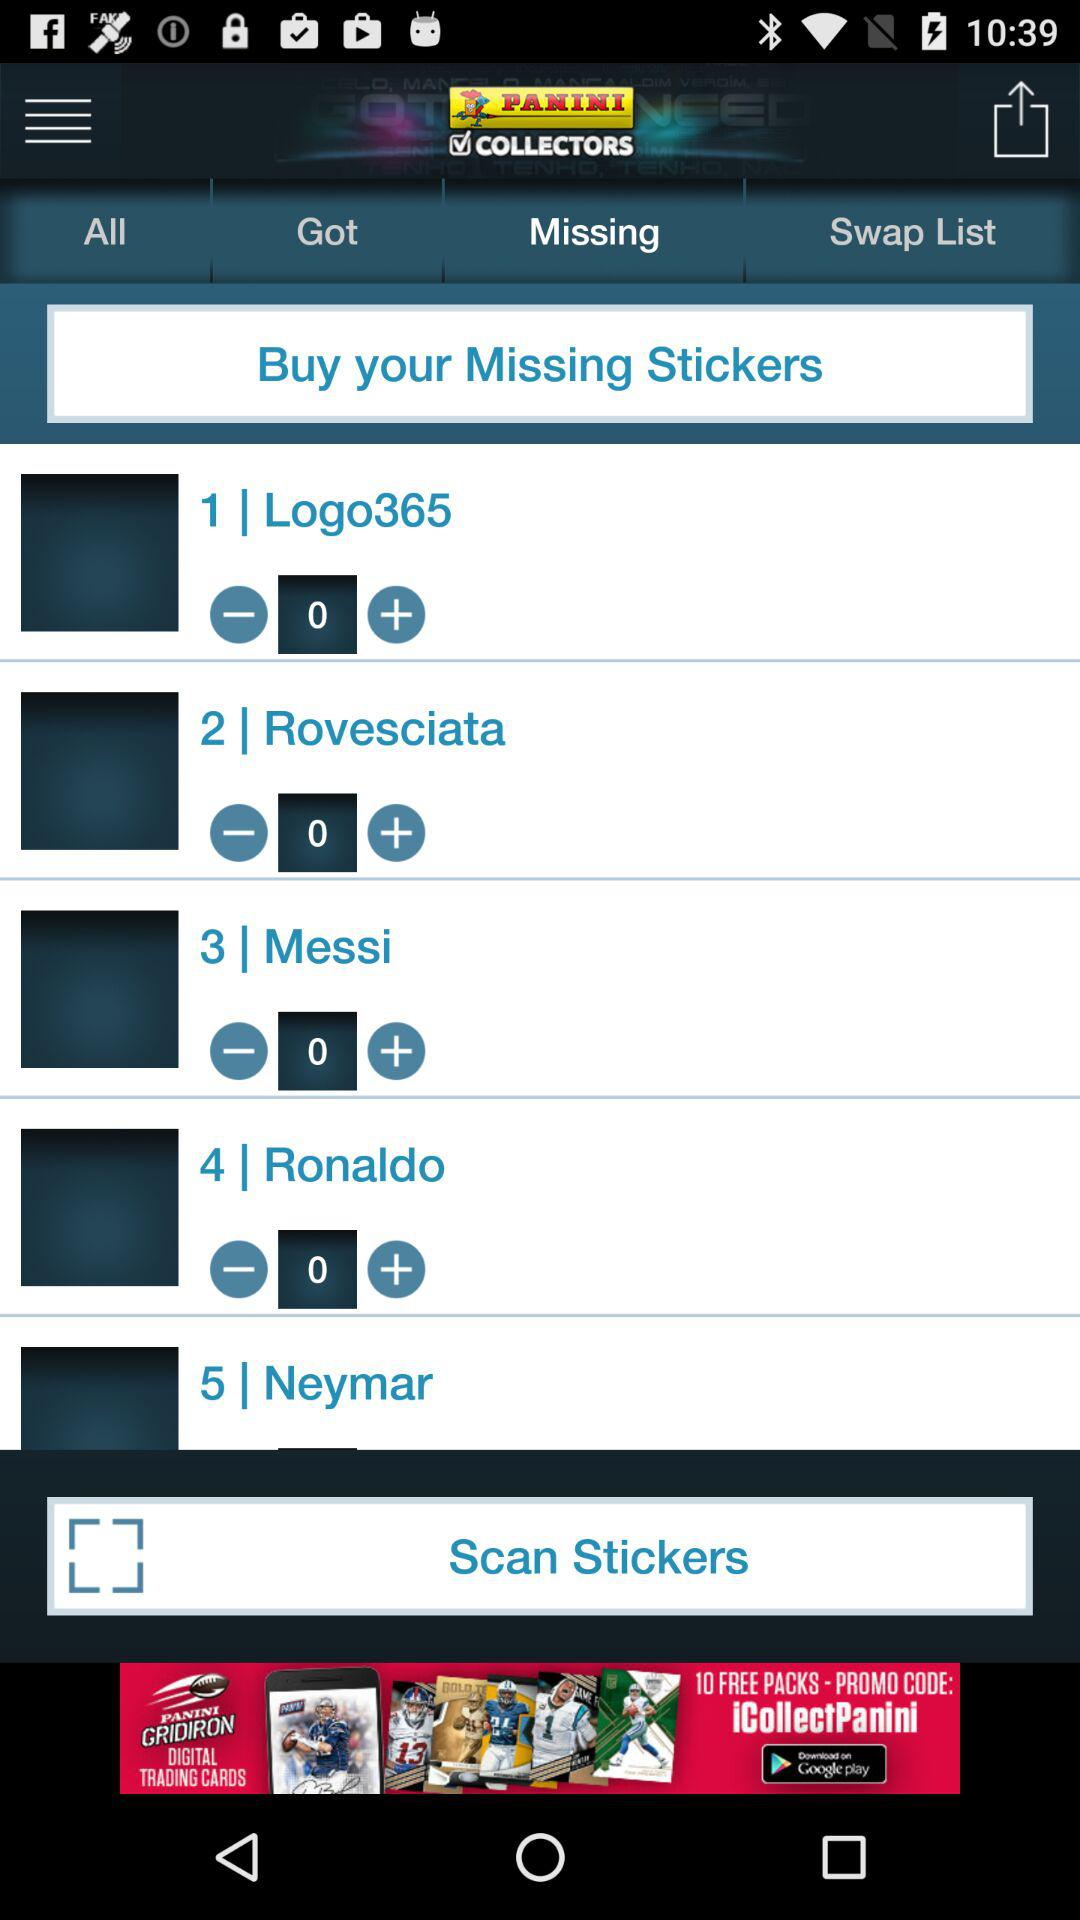What is the selected option? The selected option is "Missing". 